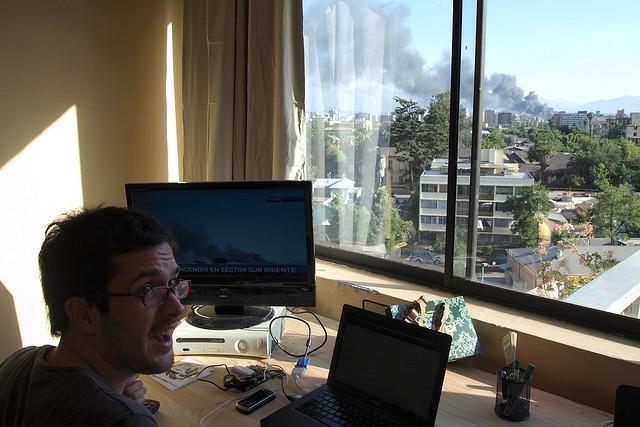How many electronic devices are on the table?
Give a very brief answer. 3. How many tvs are there?
Give a very brief answer. 2. 